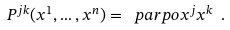Convert formula to latex. <formula><loc_0><loc_0><loc_500><loc_500>P ^ { j k } ( x ^ { 1 } , \dots , x ^ { n } ) = \ p a r p o { x ^ { j } } { x ^ { k } } \ .</formula> 